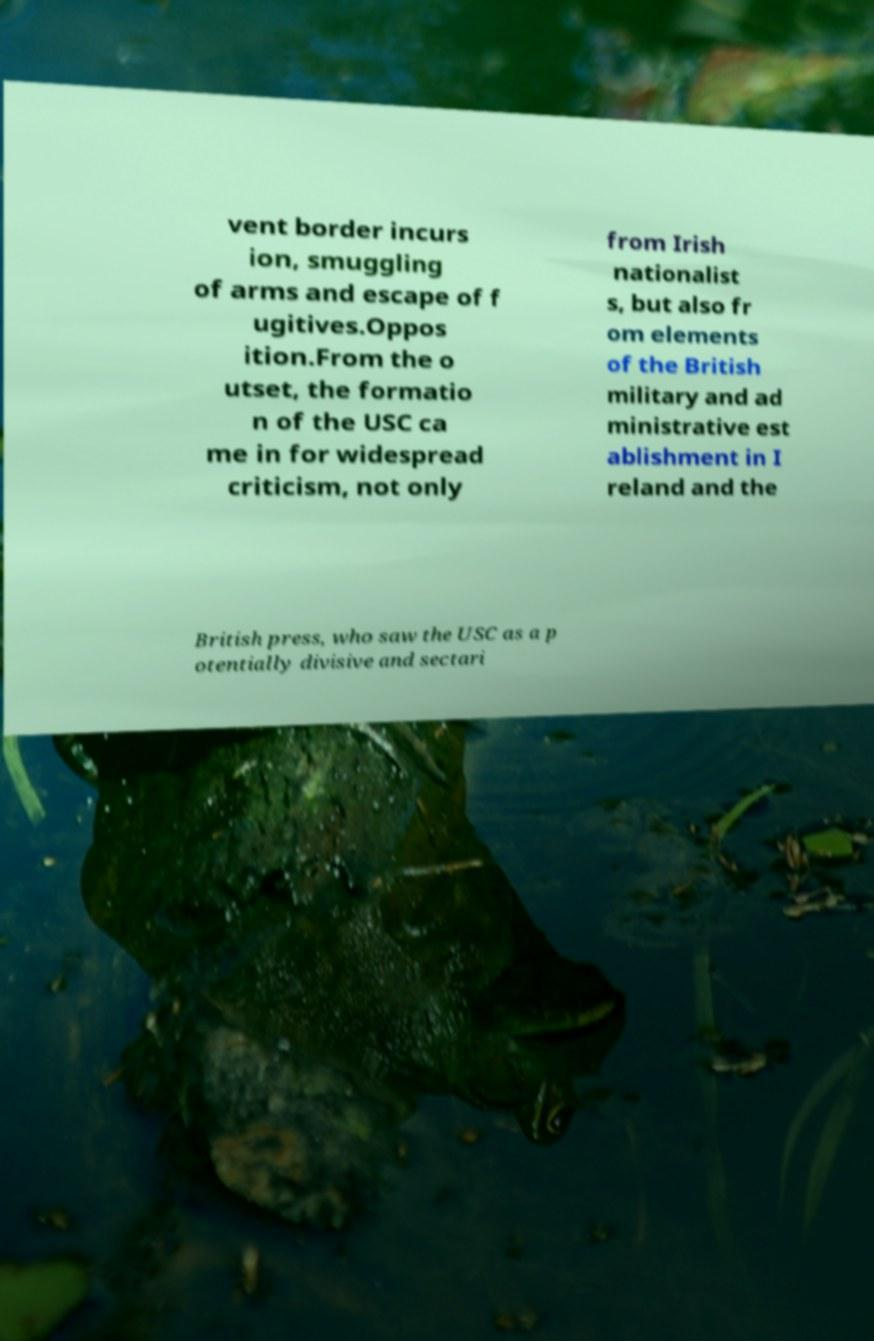Can you accurately transcribe the text from the provided image for me? vent border incurs ion, smuggling of arms and escape of f ugitives.Oppos ition.From the o utset, the formatio n of the USC ca me in for widespread criticism, not only from Irish nationalist s, but also fr om elements of the British military and ad ministrative est ablishment in I reland and the British press, who saw the USC as a p otentially divisive and sectari 